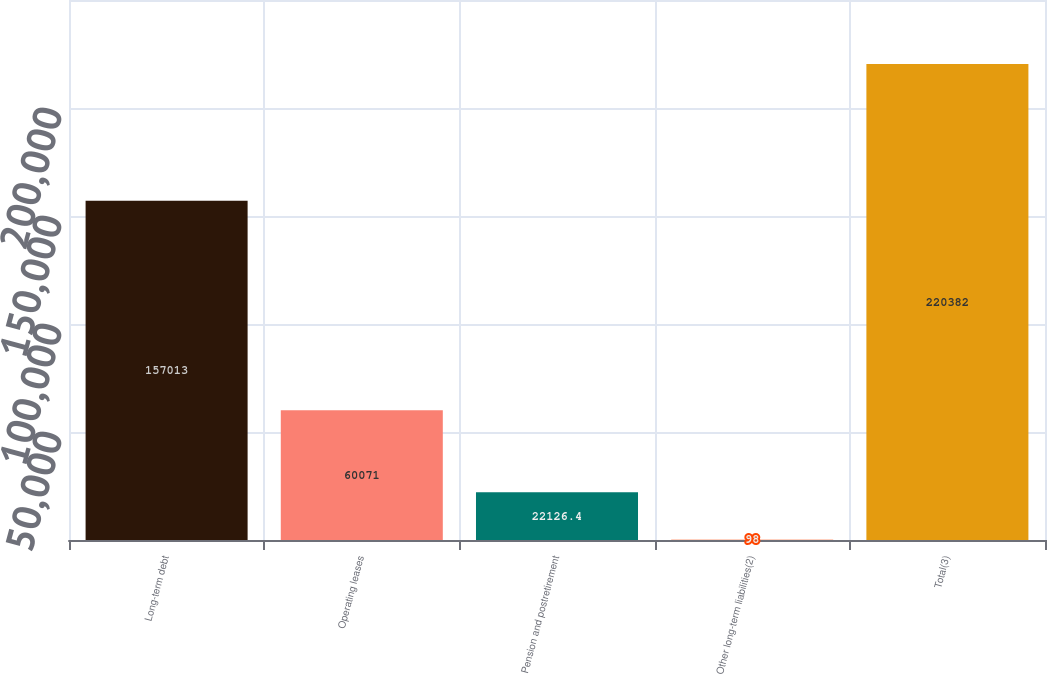<chart> <loc_0><loc_0><loc_500><loc_500><bar_chart><fcel>Long-term debt<fcel>Operating leases<fcel>Pension and postretirement<fcel>Other long-term liabilities(2)<fcel>Total(3)<nl><fcel>157013<fcel>60071<fcel>22126.4<fcel>98<fcel>220382<nl></chart> 